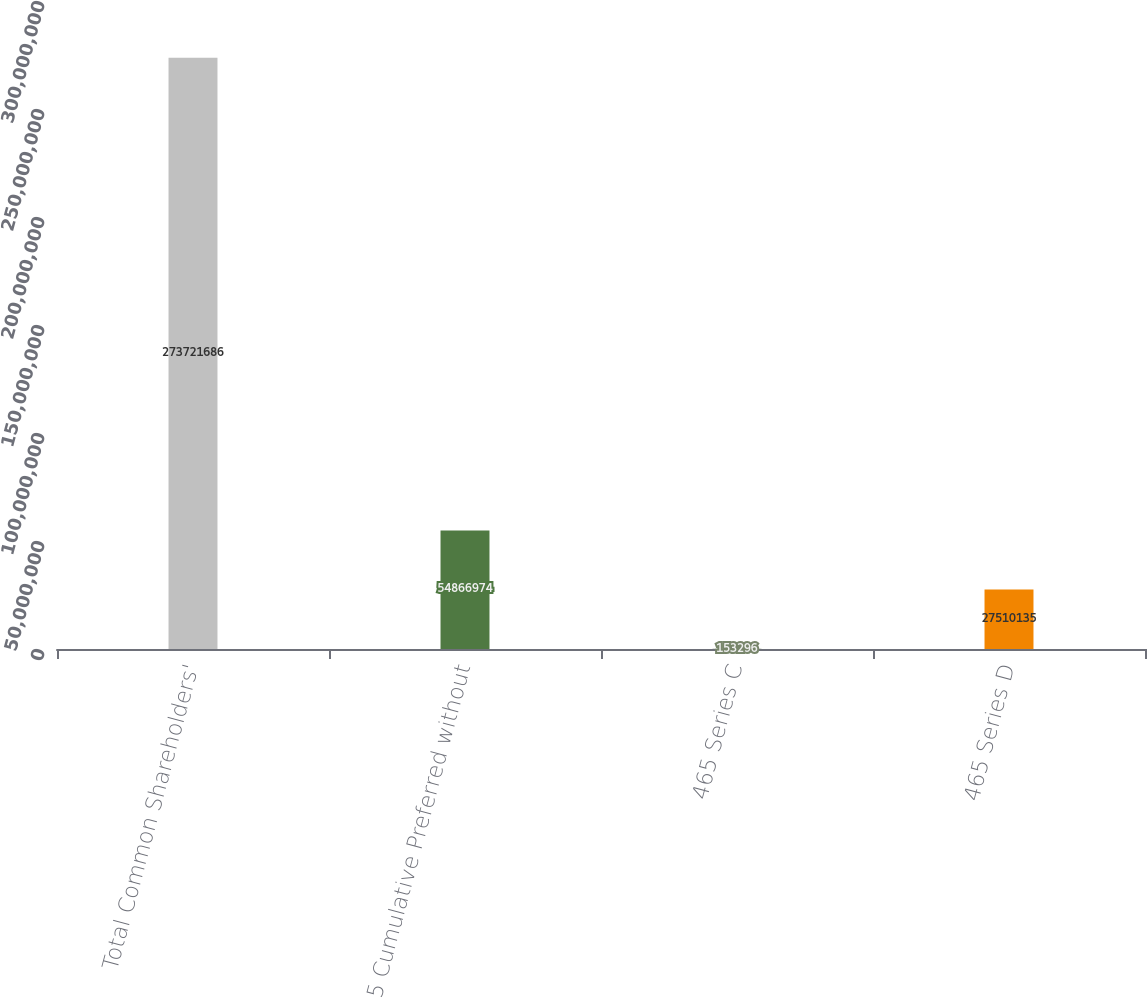Convert chart to OTSL. <chart><loc_0><loc_0><loc_500><loc_500><bar_chart><fcel>Total Common Shareholders'<fcel>5 Cumulative Preferred without<fcel>465 Series C<fcel>465 Series D<nl><fcel>2.73722e+08<fcel>5.4867e+07<fcel>153296<fcel>2.75101e+07<nl></chart> 